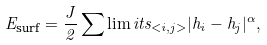<formula> <loc_0><loc_0><loc_500><loc_500>E _ { \text {surf} } = \frac { J } { 2 } \sum \lim i t s _ { < i , j > } | h _ { i } - h _ { j } | ^ { \alpha } ,</formula> 